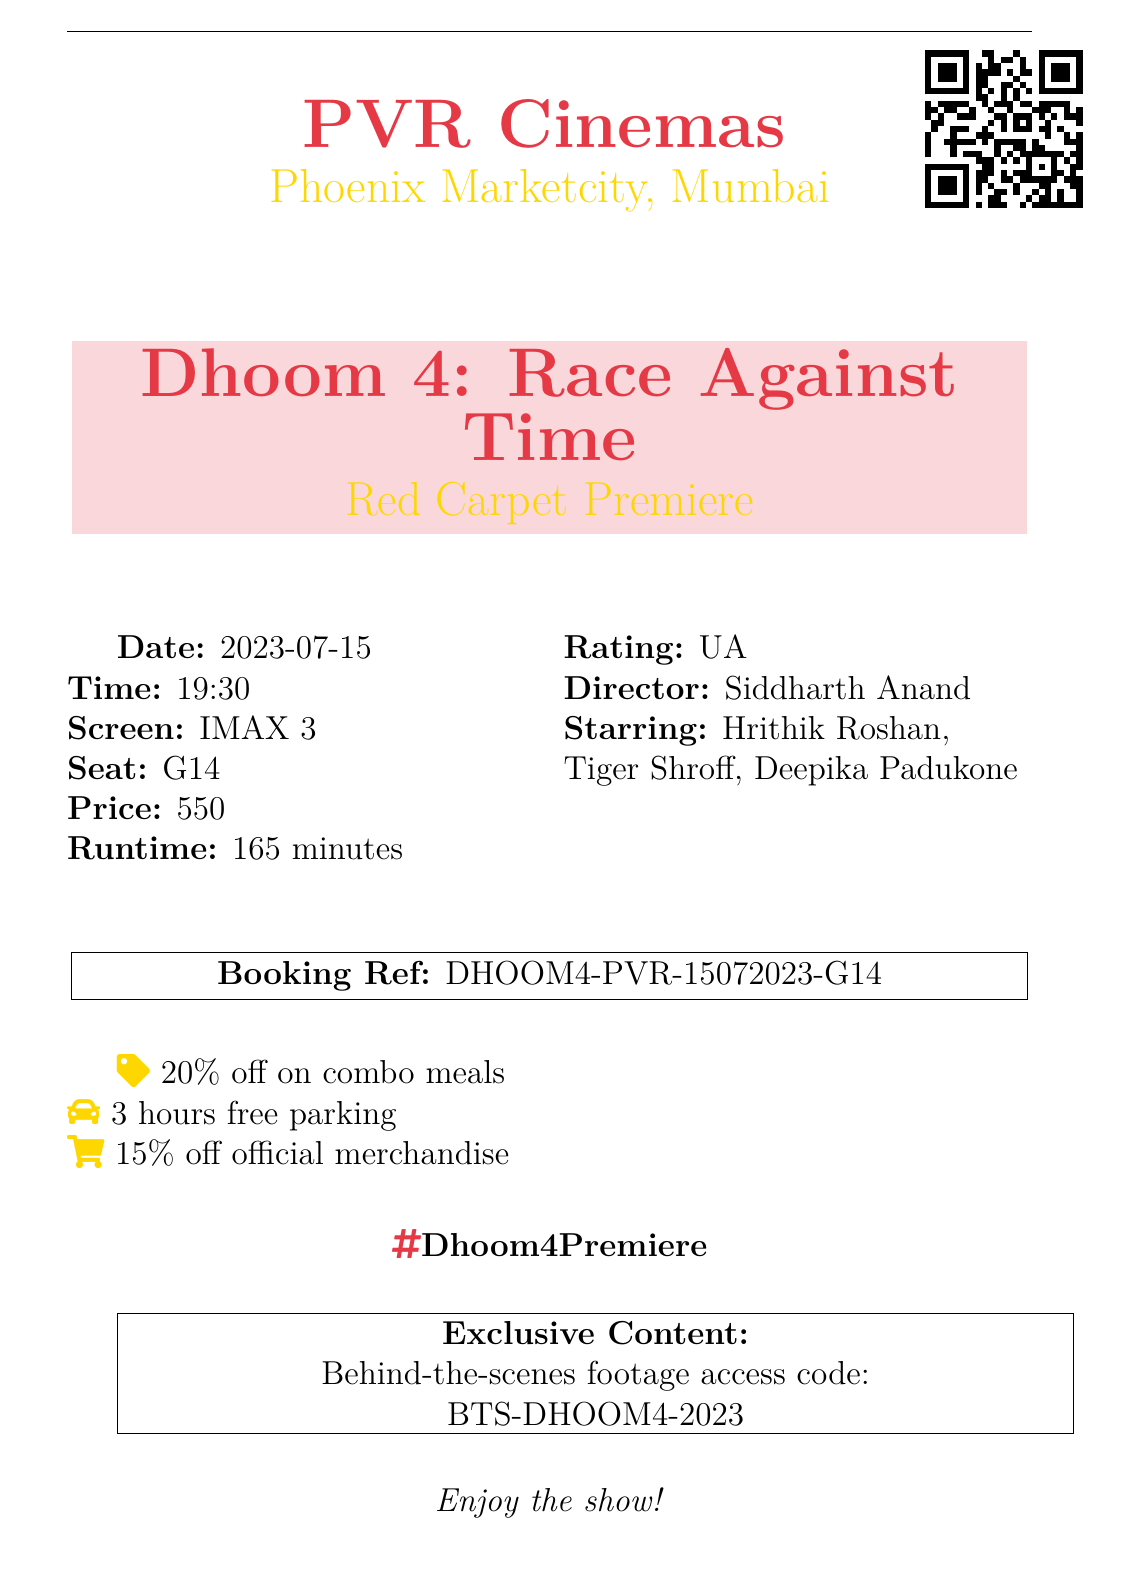What is the location of the theater? The theater is located in Mumbai, Maharashtra.
Answer: Mumbai, Maharashtra What is the movie title? The title of the movie being premiered is clearly stated on the ticket stub.
Answer: Dhoom 4: Race Against Time What is the seat number for the ticket? The seat number is explicitly mentioned in the document.
Answer: G14 What was the ticket price? The ticket price is listed in the receipt.
Answer: ₹550 What is the showtime? The document specifies the showtime for the premiere event.
Answer: 19:30 Who are the main stars of the movie? The document lists the stars prominently.
Answer: Hrithik Roshan, Tiger Shroff, Deepika Padukone What special event is being held? The type of premiere event is referred to in the ticket stub.
Answer: Red Carpet Premiere What is the age rating of the film? The rating is mentioned to inform viewers about suitability.
Answer: UA How long is the runtime of the film? The runtime details are provided in the document.
Answer: 165 minutes What do you get with the parking validation? The document describes available parking options.
Answer: 3 hours free parking 